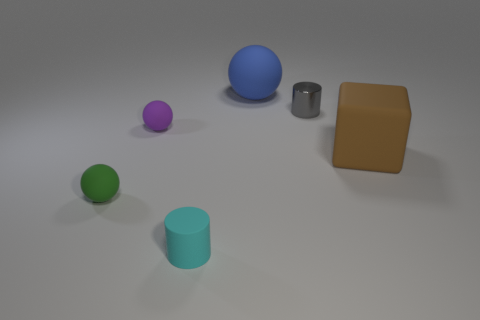Add 1 matte balls. How many objects exist? 7 Subtract all tiny spheres. How many spheres are left? 1 Subtract all green spheres. How many spheres are left? 2 Subtract all cyan cubes. Subtract all green spheres. How many cubes are left? 1 Subtract all yellow blocks. How many green balls are left? 1 Subtract all green spheres. Subtract all cyan objects. How many objects are left? 4 Add 3 rubber cubes. How many rubber cubes are left? 4 Add 1 small gray things. How many small gray things exist? 2 Subtract 1 gray cylinders. How many objects are left? 5 Subtract all cubes. How many objects are left? 5 